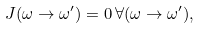Convert formula to latex. <formula><loc_0><loc_0><loc_500><loc_500>J ( \omega \to \omega ^ { \prime } ) = 0 \, \forall ( \omega \to \omega ^ { \prime } ) ,</formula> 